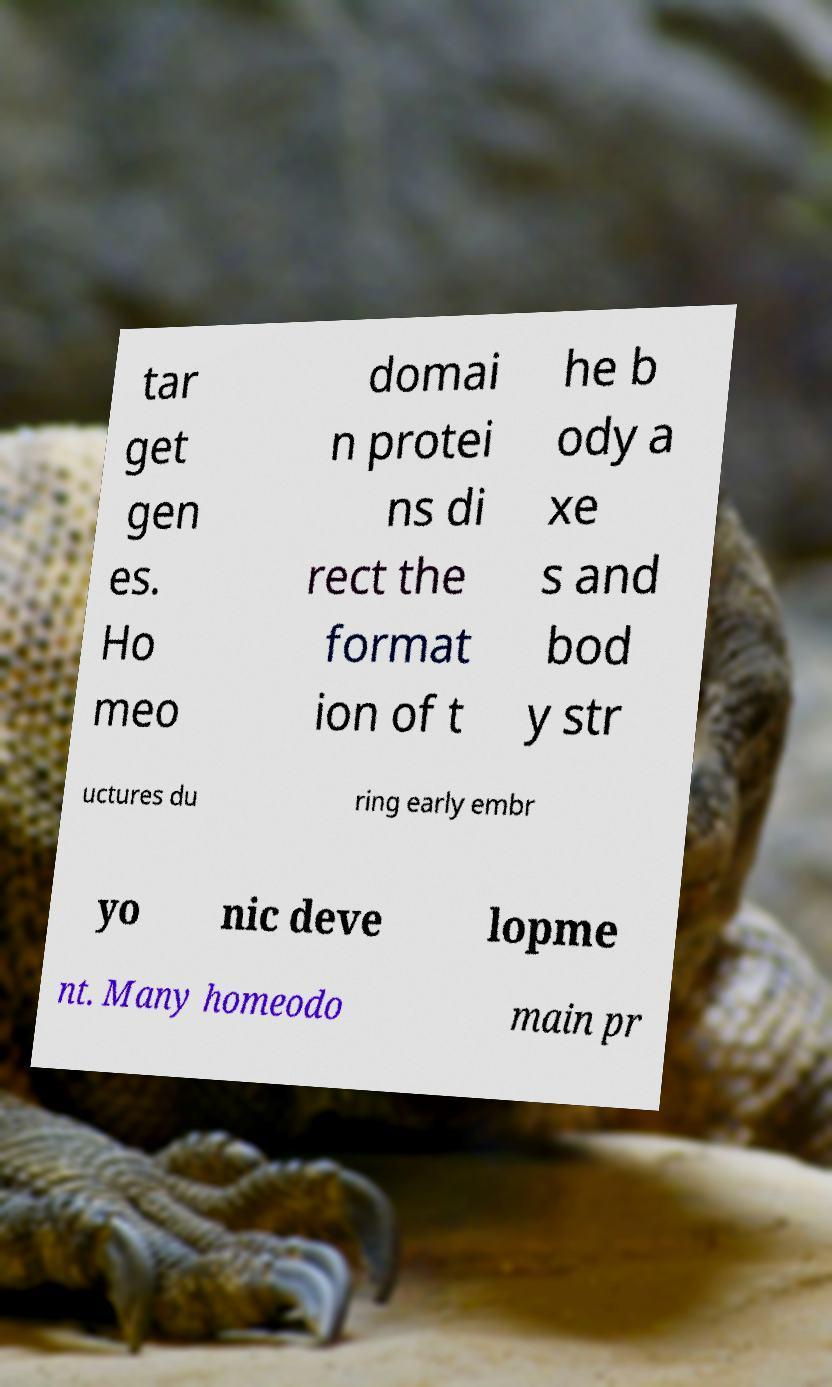For documentation purposes, I need the text within this image transcribed. Could you provide that? tar get gen es. Ho meo domai n protei ns di rect the format ion of t he b ody a xe s and bod y str uctures du ring early embr yo nic deve lopme nt. Many homeodo main pr 